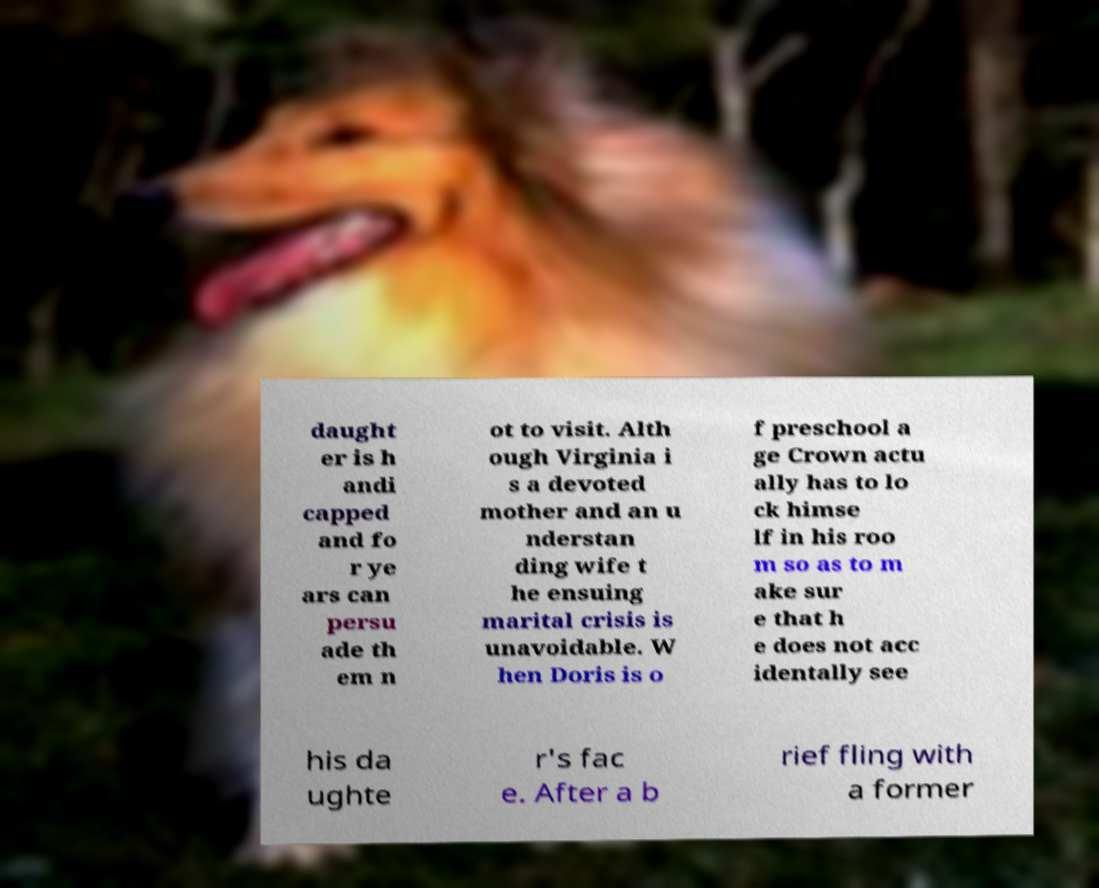Please identify and transcribe the text found in this image. daught er is h andi capped and fo r ye ars can persu ade th em n ot to visit. Alth ough Virginia i s a devoted mother and an u nderstan ding wife t he ensuing marital crisis is unavoidable. W hen Doris is o f preschool a ge Crown actu ally has to lo ck himse lf in his roo m so as to m ake sur e that h e does not acc identally see his da ughte r's fac e. After a b rief fling with a former 